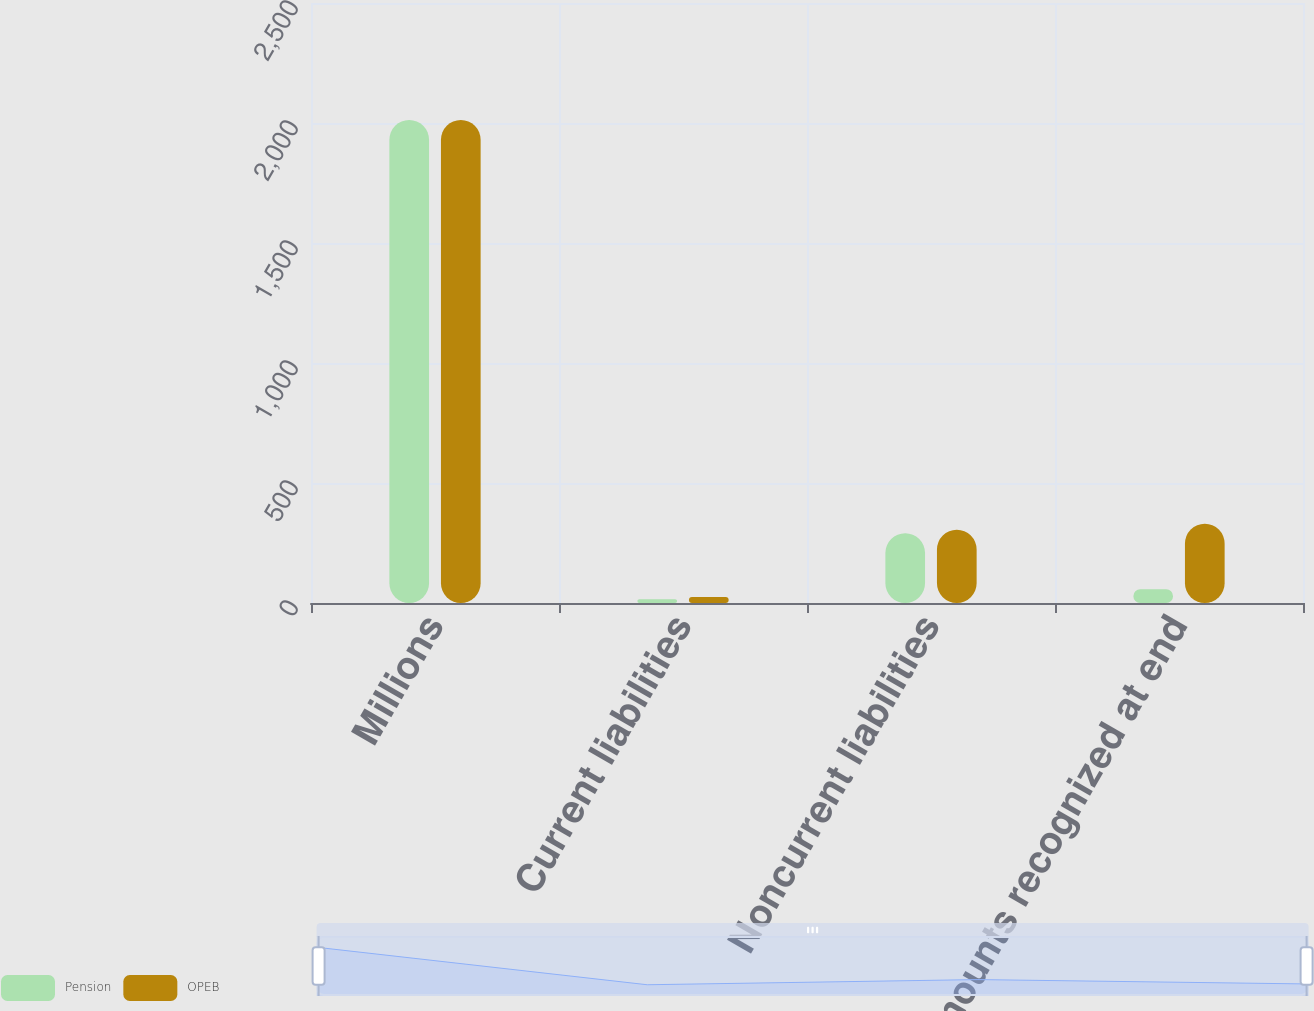Convert chart to OTSL. <chart><loc_0><loc_0><loc_500><loc_500><stacked_bar_chart><ecel><fcel>Millions<fcel>Current liabilities<fcel>Noncurrent liabilities<fcel>Net amounts recognized at end<nl><fcel>Pension<fcel>2013<fcel>16<fcel>291<fcel>57<nl><fcel>OPEB<fcel>2013<fcel>25<fcel>305<fcel>330<nl></chart> 